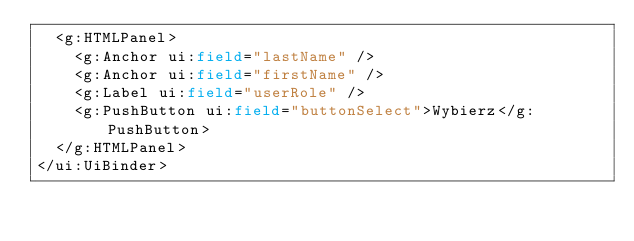<code> <loc_0><loc_0><loc_500><loc_500><_XML_>	<g:HTMLPanel>
		<g:Anchor ui:field="lastName" />
		<g:Anchor ui:field="firstName" />
		<g:Label ui:field="userRole" />
		<g:PushButton ui:field="buttonSelect">Wybierz</g:PushButton>
	</g:HTMLPanel>
</ui:UiBinder> </code> 